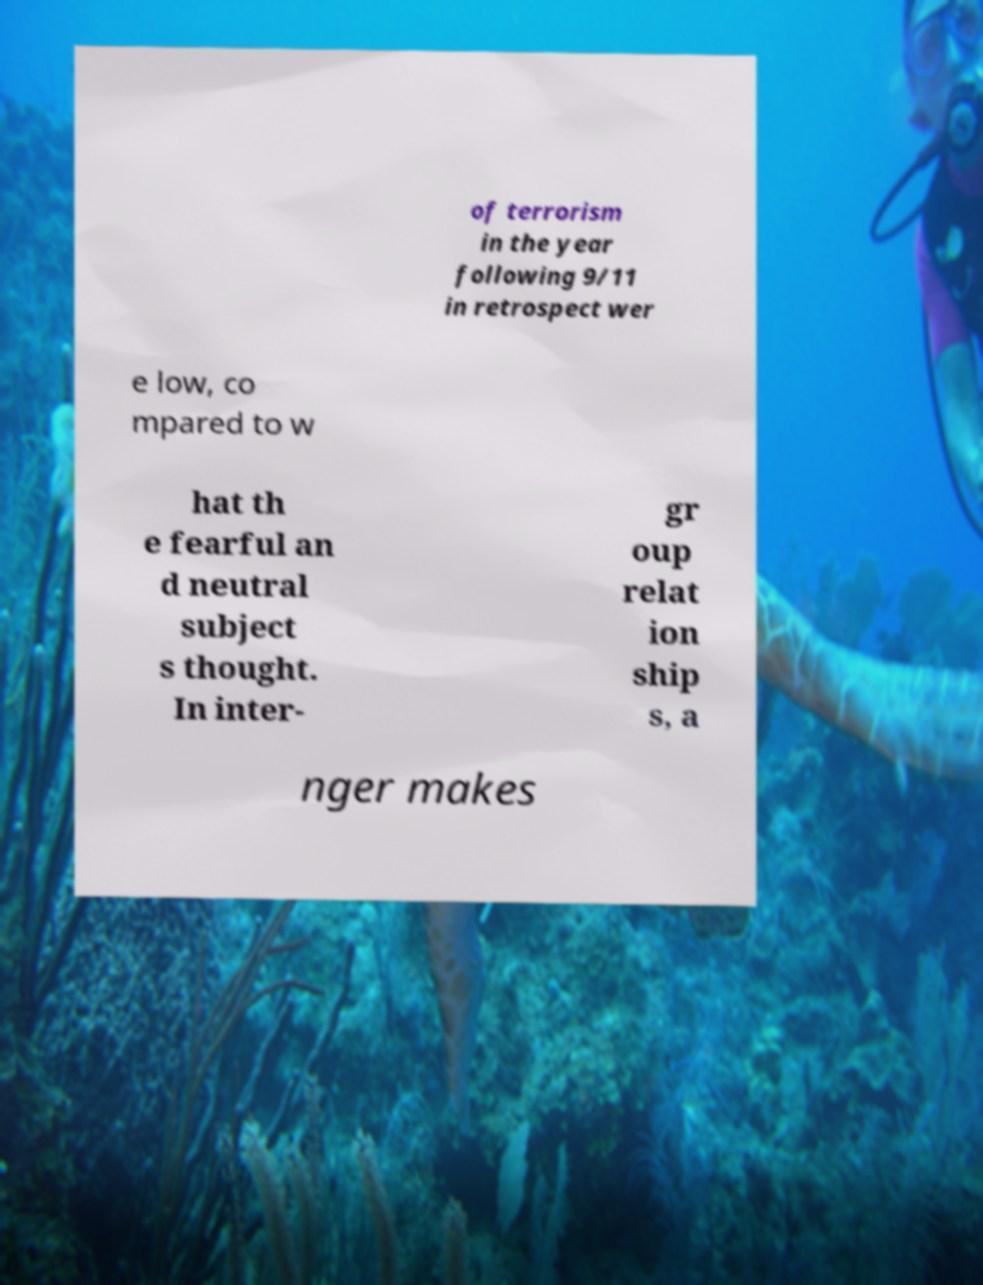There's text embedded in this image that I need extracted. Can you transcribe it verbatim? of terrorism in the year following 9/11 in retrospect wer e low, co mpared to w hat th e fearful an d neutral subject s thought. In inter- gr oup relat ion ship s, a nger makes 